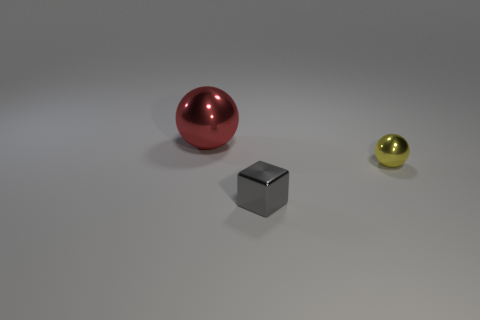Are there any other things that have the same size as the red thing?
Offer a terse response. No. Is there anything else of the same color as the big ball?
Offer a very short reply. No. Does the object that is in front of the tiny yellow metallic ball have the same shape as the metallic object that is behind the tiny yellow metal thing?
Keep it short and to the point. No. Are there the same number of large spheres that are behind the tiny gray thing and big things?
Give a very brief answer. Yes. How many gray cylinders are the same material as the big red ball?
Keep it short and to the point. 0. The small sphere that is the same material as the small gray block is what color?
Your response must be concise. Yellow. Do the gray thing and the metallic object that is on the left side of the small gray object have the same size?
Provide a succinct answer. No. What shape is the red shiny thing?
Ensure brevity in your answer.  Sphere. What number of small balls are the same color as the small shiny block?
Your answer should be compact. 0. What color is the other metal object that is the same shape as the red object?
Give a very brief answer. Yellow. 